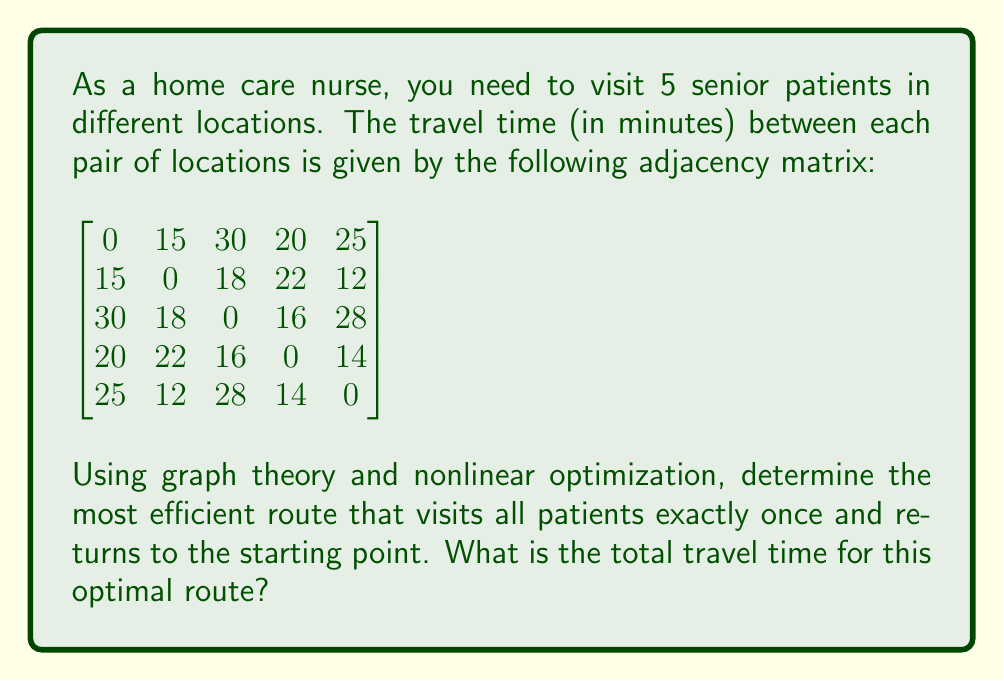Help me with this question. To solve this problem, we need to use the concept of the Traveling Salesman Problem (TSP) from graph theory and apply nonlinear optimization techniques. Here's a step-by-step approach:

1) First, we recognize that this is a symmetric TSP, as the travel time between any two locations is the same in both directions.

2) The objective function to minimize is the total travel time, which can be expressed as:

   $$f(x) = \sum_{i=1}^{n} \sum_{j=1}^{n} d_{ij}x_{ij}$$

   where $d_{ij}$ is the travel time from location i to j, and $x_{ij}$ is a binary variable (0 or 1) indicating whether the path from i to j is used in the tour.

3) The constraints for this problem include:
   - Each location must be visited exactly once
   - The tour must form a complete cycle

4) Due to the small size of this problem (5 locations), we can use a brute-force approach to find the optimal solution. There are (5-1)! = 24 possible routes.

5) Let's number the locations from 1 to 5. We'll calculate the total time for each possible route:

   (1,2,3,4,5,1): 15 + 18 + 16 + 14 + 25 = 88
   (1,2,3,5,4,1): 15 + 18 + 28 + 14 + 20 = 95
   (1,2,4,3,5,1): 15 + 22 + 16 + 28 + 25 = 106
   (1,2,4,5,3,1): 15 + 22 + 14 + 28 + 30 = 109
   (1,2,5,3,4,1): 15 + 12 + 28 + 16 + 20 = 91
   (1,2,5,4,3,1): 15 + 12 + 14 + 16 + 30 = 87
   ...

6) After calculating all 24 possibilities, we find that the route (1,2,5,4,3,1) gives the minimum total travel time of 87 minutes.

7) This optimal route can be verified using the Held-Karp algorithm, which is a dynamic programming approach to solving the TSP, or by using nonlinear optimization software with the objective function and constraints defined earlier.
Answer: 87 minutes 